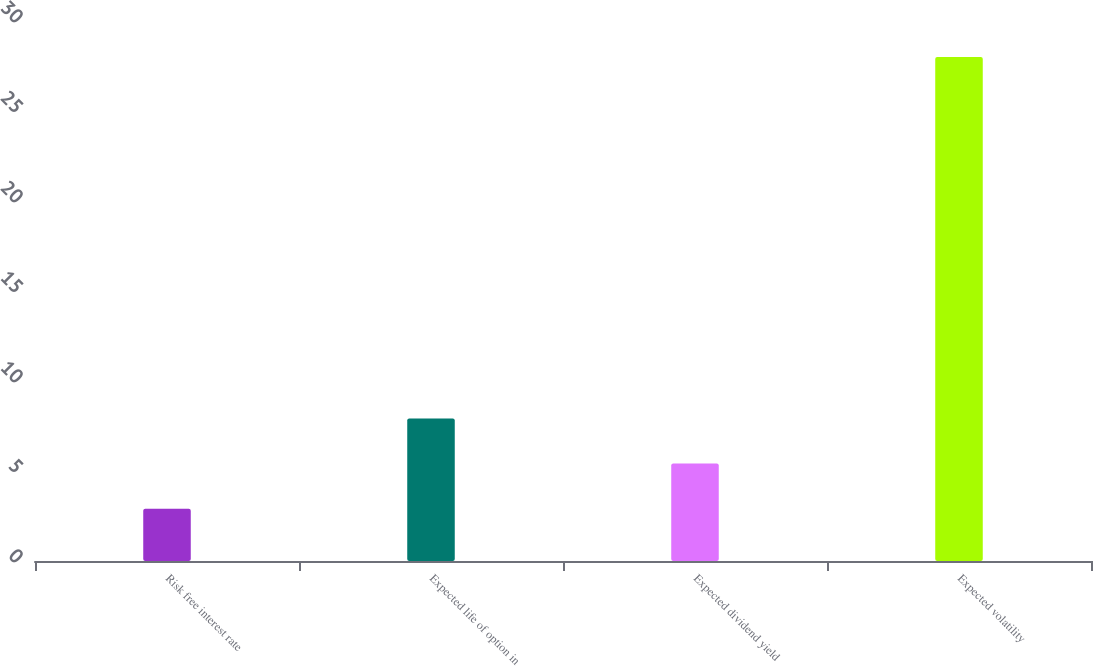Convert chart. <chart><loc_0><loc_0><loc_500><loc_500><bar_chart><fcel>Risk free interest rate<fcel>Expected life of option in<fcel>Expected dividend yield<fcel>Expected volatility<nl><fcel>2.9<fcel>7.92<fcel>5.41<fcel>28<nl></chart> 